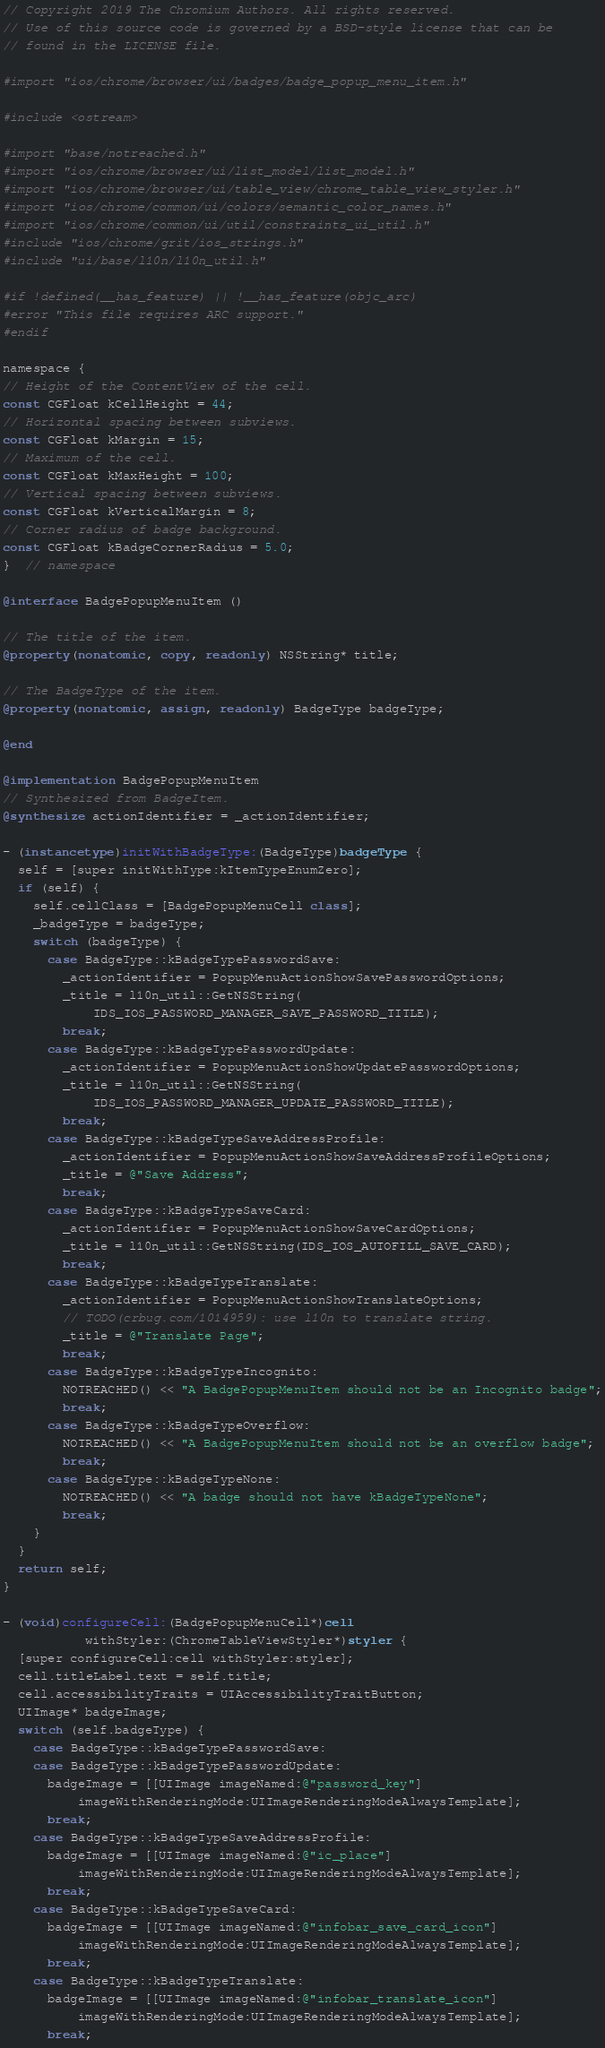<code> <loc_0><loc_0><loc_500><loc_500><_ObjectiveC_>// Copyright 2019 The Chromium Authors. All rights reserved.
// Use of this source code is governed by a BSD-style license that can be
// found in the LICENSE file.

#import "ios/chrome/browser/ui/badges/badge_popup_menu_item.h"

#include <ostream>

#import "base/notreached.h"
#import "ios/chrome/browser/ui/list_model/list_model.h"
#import "ios/chrome/browser/ui/table_view/chrome_table_view_styler.h"
#import "ios/chrome/common/ui/colors/semantic_color_names.h"
#import "ios/chrome/common/ui/util/constraints_ui_util.h"
#include "ios/chrome/grit/ios_strings.h"
#include "ui/base/l10n/l10n_util.h"

#if !defined(__has_feature) || !__has_feature(objc_arc)
#error "This file requires ARC support."
#endif

namespace {
// Height of the ContentView of the cell.
const CGFloat kCellHeight = 44;
// Horizontal spacing between subviews.
const CGFloat kMargin = 15;
// Maximum of the cell.
const CGFloat kMaxHeight = 100;
// Vertical spacing between subviews.
const CGFloat kVerticalMargin = 8;
// Corner radius of badge background.
const CGFloat kBadgeCornerRadius = 5.0;
}  // namespace

@interface BadgePopupMenuItem ()

// The title of the item.
@property(nonatomic, copy, readonly) NSString* title;

// The BadgeType of the item.
@property(nonatomic, assign, readonly) BadgeType badgeType;

@end

@implementation BadgePopupMenuItem
// Synthesized from BadgeItem.
@synthesize actionIdentifier = _actionIdentifier;

- (instancetype)initWithBadgeType:(BadgeType)badgeType {
  self = [super initWithType:kItemTypeEnumZero];
  if (self) {
    self.cellClass = [BadgePopupMenuCell class];
    _badgeType = badgeType;
    switch (badgeType) {
      case BadgeType::kBadgeTypePasswordSave:
        _actionIdentifier = PopupMenuActionShowSavePasswordOptions;
        _title = l10n_util::GetNSString(
            IDS_IOS_PASSWORD_MANAGER_SAVE_PASSWORD_TITLE);
        break;
      case BadgeType::kBadgeTypePasswordUpdate:
        _actionIdentifier = PopupMenuActionShowUpdatePasswordOptions;
        _title = l10n_util::GetNSString(
            IDS_IOS_PASSWORD_MANAGER_UPDATE_PASSWORD_TITLE);
        break;
      case BadgeType::kBadgeTypeSaveAddressProfile:
        _actionIdentifier = PopupMenuActionShowSaveAddressProfileOptions;
        _title = @"Save Address";
        break;
      case BadgeType::kBadgeTypeSaveCard:
        _actionIdentifier = PopupMenuActionShowSaveCardOptions;
        _title = l10n_util::GetNSString(IDS_IOS_AUTOFILL_SAVE_CARD);
        break;
      case BadgeType::kBadgeTypeTranslate:
        _actionIdentifier = PopupMenuActionShowTranslateOptions;
        // TODO(crbug.com/1014959): use l10n to translate string.
        _title = @"Translate Page";
        break;
      case BadgeType::kBadgeTypeIncognito:
        NOTREACHED() << "A BadgePopupMenuItem should not be an Incognito badge";
        break;
      case BadgeType::kBadgeTypeOverflow:
        NOTREACHED() << "A BadgePopupMenuItem should not be an overflow badge";
        break;
      case BadgeType::kBadgeTypeNone:
        NOTREACHED() << "A badge should not have kBadgeTypeNone";
        break;
    }
  }
  return self;
}

- (void)configureCell:(BadgePopupMenuCell*)cell
           withStyler:(ChromeTableViewStyler*)styler {
  [super configureCell:cell withStyler:styler];
  cell.titleLabel.text = self.title;
  cell.accessibilityTraits = UIAccessibilityTraitButton;
  UIImage* badgeImage;
  switch (self.badgeType) {
    case BadgeType::kBadgeTypePasswordSave:
    case BadgeType::kBadgeTypePasswordUpdate:
      badgeImage = [[UIImage imageNamed:@"password_key"]
          imageWithRenderingMode:UIImageRenderingModeAlwaysTemplate];
      break;
    case BadgeType::kBadgeTypeSaveAddressProfile:
      badgeImage = [[UIImage imageNamed:@"ic_place"]
          imageWithRenderingMode:UIImageRenderingModeAlwaysTemplate];
      break;
    case BadgeType::kBadgeTypeSaveCard:
      badgeImage = [[UIImage imageNamed:@"infobar_save_card_icon"]
          imageWithRenderingMode:UIImageRenderingModeAlwaysTemplate];
      break;
    case BadgeType::kBadgeTypeTranslate:
      badgeImage = [[UIImage imageNamed:@"infobar_translate_icon"]
          imageWithRenderingMode:UIImageRenderingModeAlwaysTemplate];
      break;</code> 